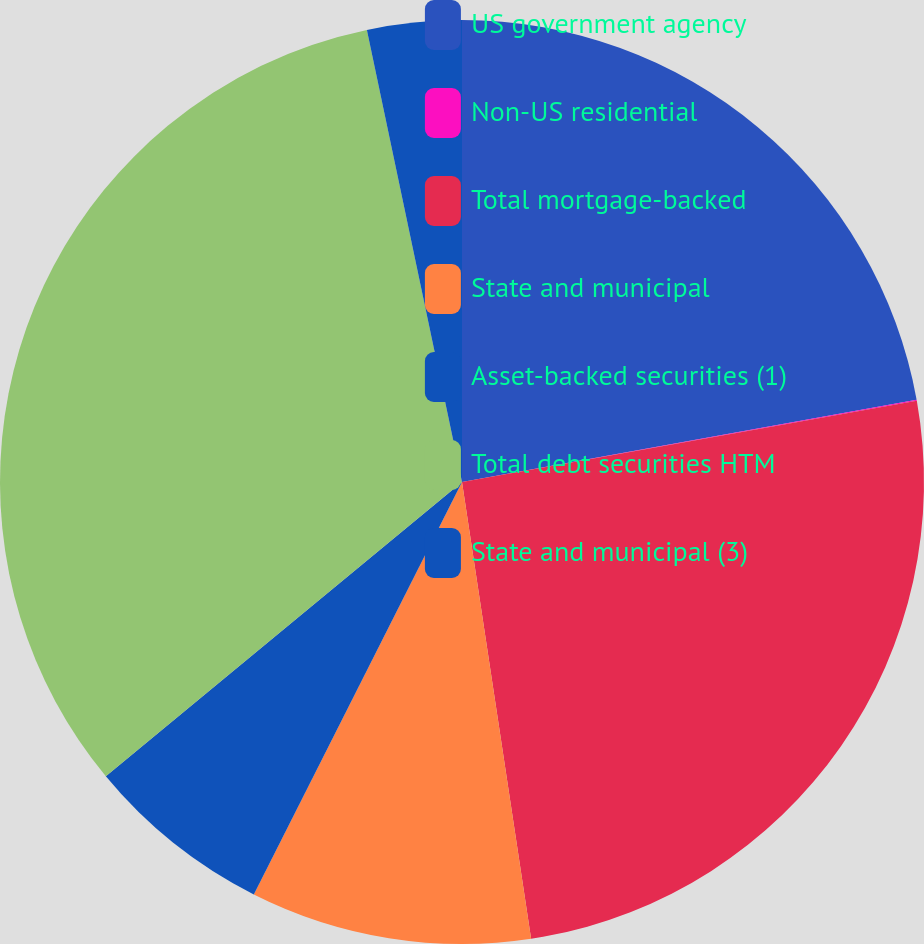Convert chart. <chart><loc_0><loc_0><loc_500><loc_500><pie_chart><fcel>US government agency<fcel>Non-US residential<fcel>Total mortgage-backed<fcel>State and municipal<fcel>Asset-backed securities (1)<fcel>Total debt securities HTM<fcel>State and municipal (3)<nl><fcel>22.15%<fcel>0.04%<fcel>25.42%<fcel>9.83%<fcel>6.57%<fcel>32.69%<fcel>3.3%<nl></chart> 